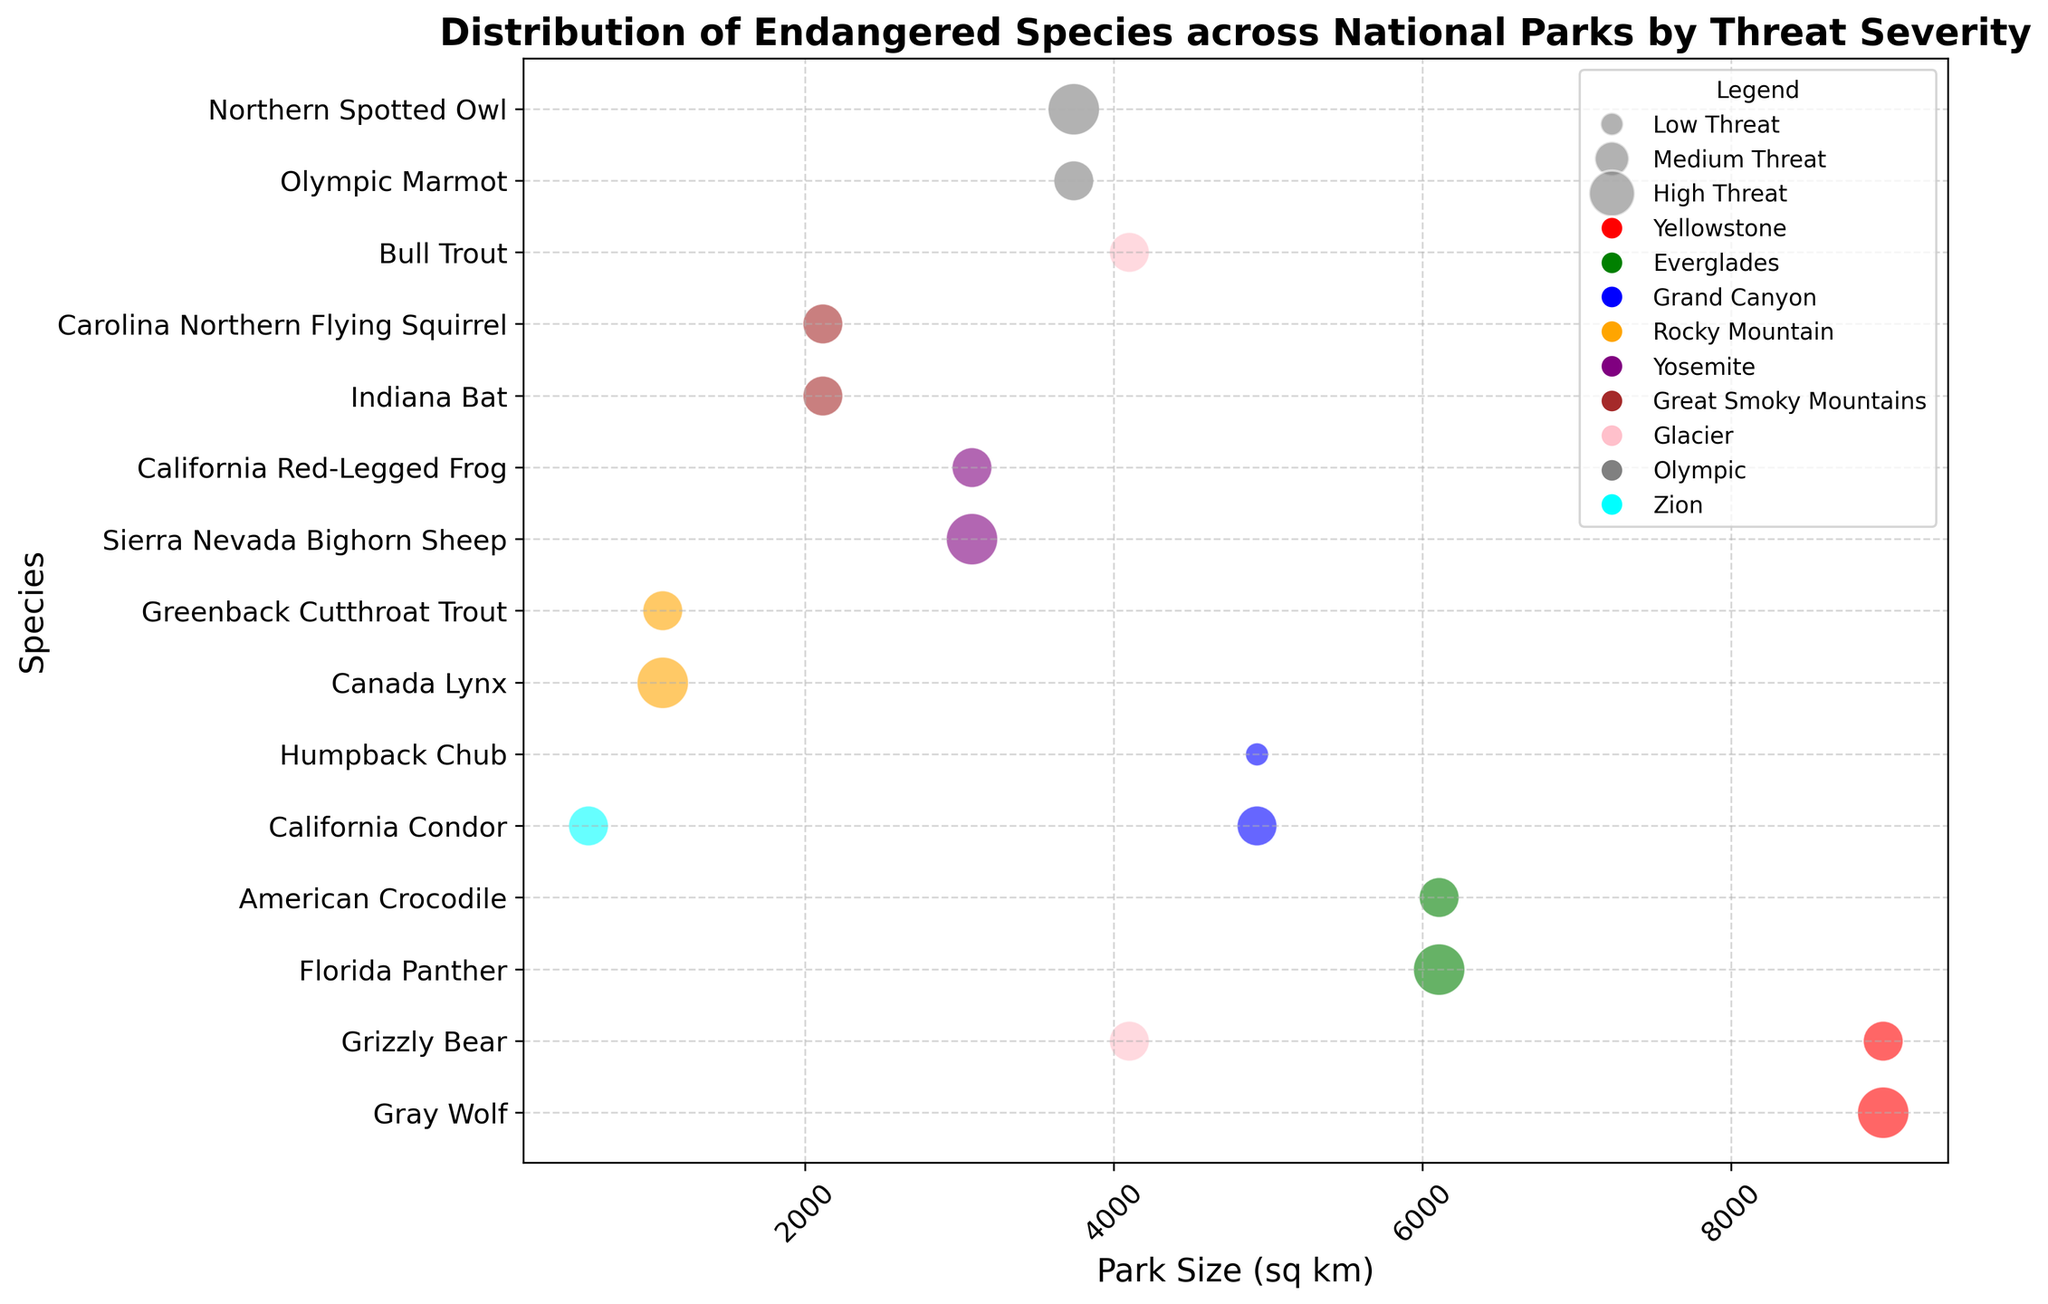What's the largest park in the figure and what species have the highest threat severity there? Identify the park with the largest size and check which species have the highest threat severity in that park. Yellowstone is visibly the largest park, and the species with the highest threat severity there is the Gray Wolf.
Answer: Gray Wolf at Yellowstone Out of Yellowstone and Everglades, which park has more species listed? Count the number of species for both Yellowstone and Everglades in the graph. Yellowstone has 2 species (Gray Wolf, Grizzly Bear), and Everglades also has 2 species (Florida Panther, American Crocodile).
Answer: Equal number of species In terms of threat severity, which species have the largest bubbles? Look for the largest (500-sized) bubbles in the figure, which correspond to the highest threat severity. The biggest bubbles are for Gray Wolf, Florida Panther, Canada Lynx, Northern Spotted Owl, and Sierra Nevada Bighorn Sheep.
Answer: Gray Wolf, Florida Panther, Canada Lynx, Northern Spotted Owl, Sierra Nevada Bighorn Sheep Which species in Grand Canyon has higher threat severity, and what level is it? Compare the threat severity (bubble size) for both species in Grand Canyon. California Condor has a medium threat level whereas Humpback Chub has a low threat level.
Answer: California Condor with a Medium threat level What is the average size of parks with "High" threat severity species? Sum the sizes of parks with species having "High" threat severity and then divide by the count of those parks. Sizes are 8983 (Yellowstone), 6105 (Everglades), 1076 (Rocky Mountain), 3081 (Yosemite), and 3739 (Olympic). Average = (8983 + 6105 + 1076 + 3081 + 3739) / 5 = 23984 / 5 = 4796.8
Answer: 4796.8 Which park has the most variety of threat severities? Identify the park with the most distinct bubble sizes (representing different threat severities). Yellowstone and Rocky Mountain each have species with both "High" and "Medium" threat severities.
Answer: Yellowstone and Rocky Mountain 